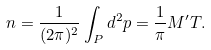<formula> <loc_0><loc_0><loc_500><loc_500>n = \frac { 1 } { ( 2 \pi ) ^ { 2 } } \int _ { P } d ^ { 2 } p = \frac { 1 } { \pi } M ^ { \prime } T .</formula> 